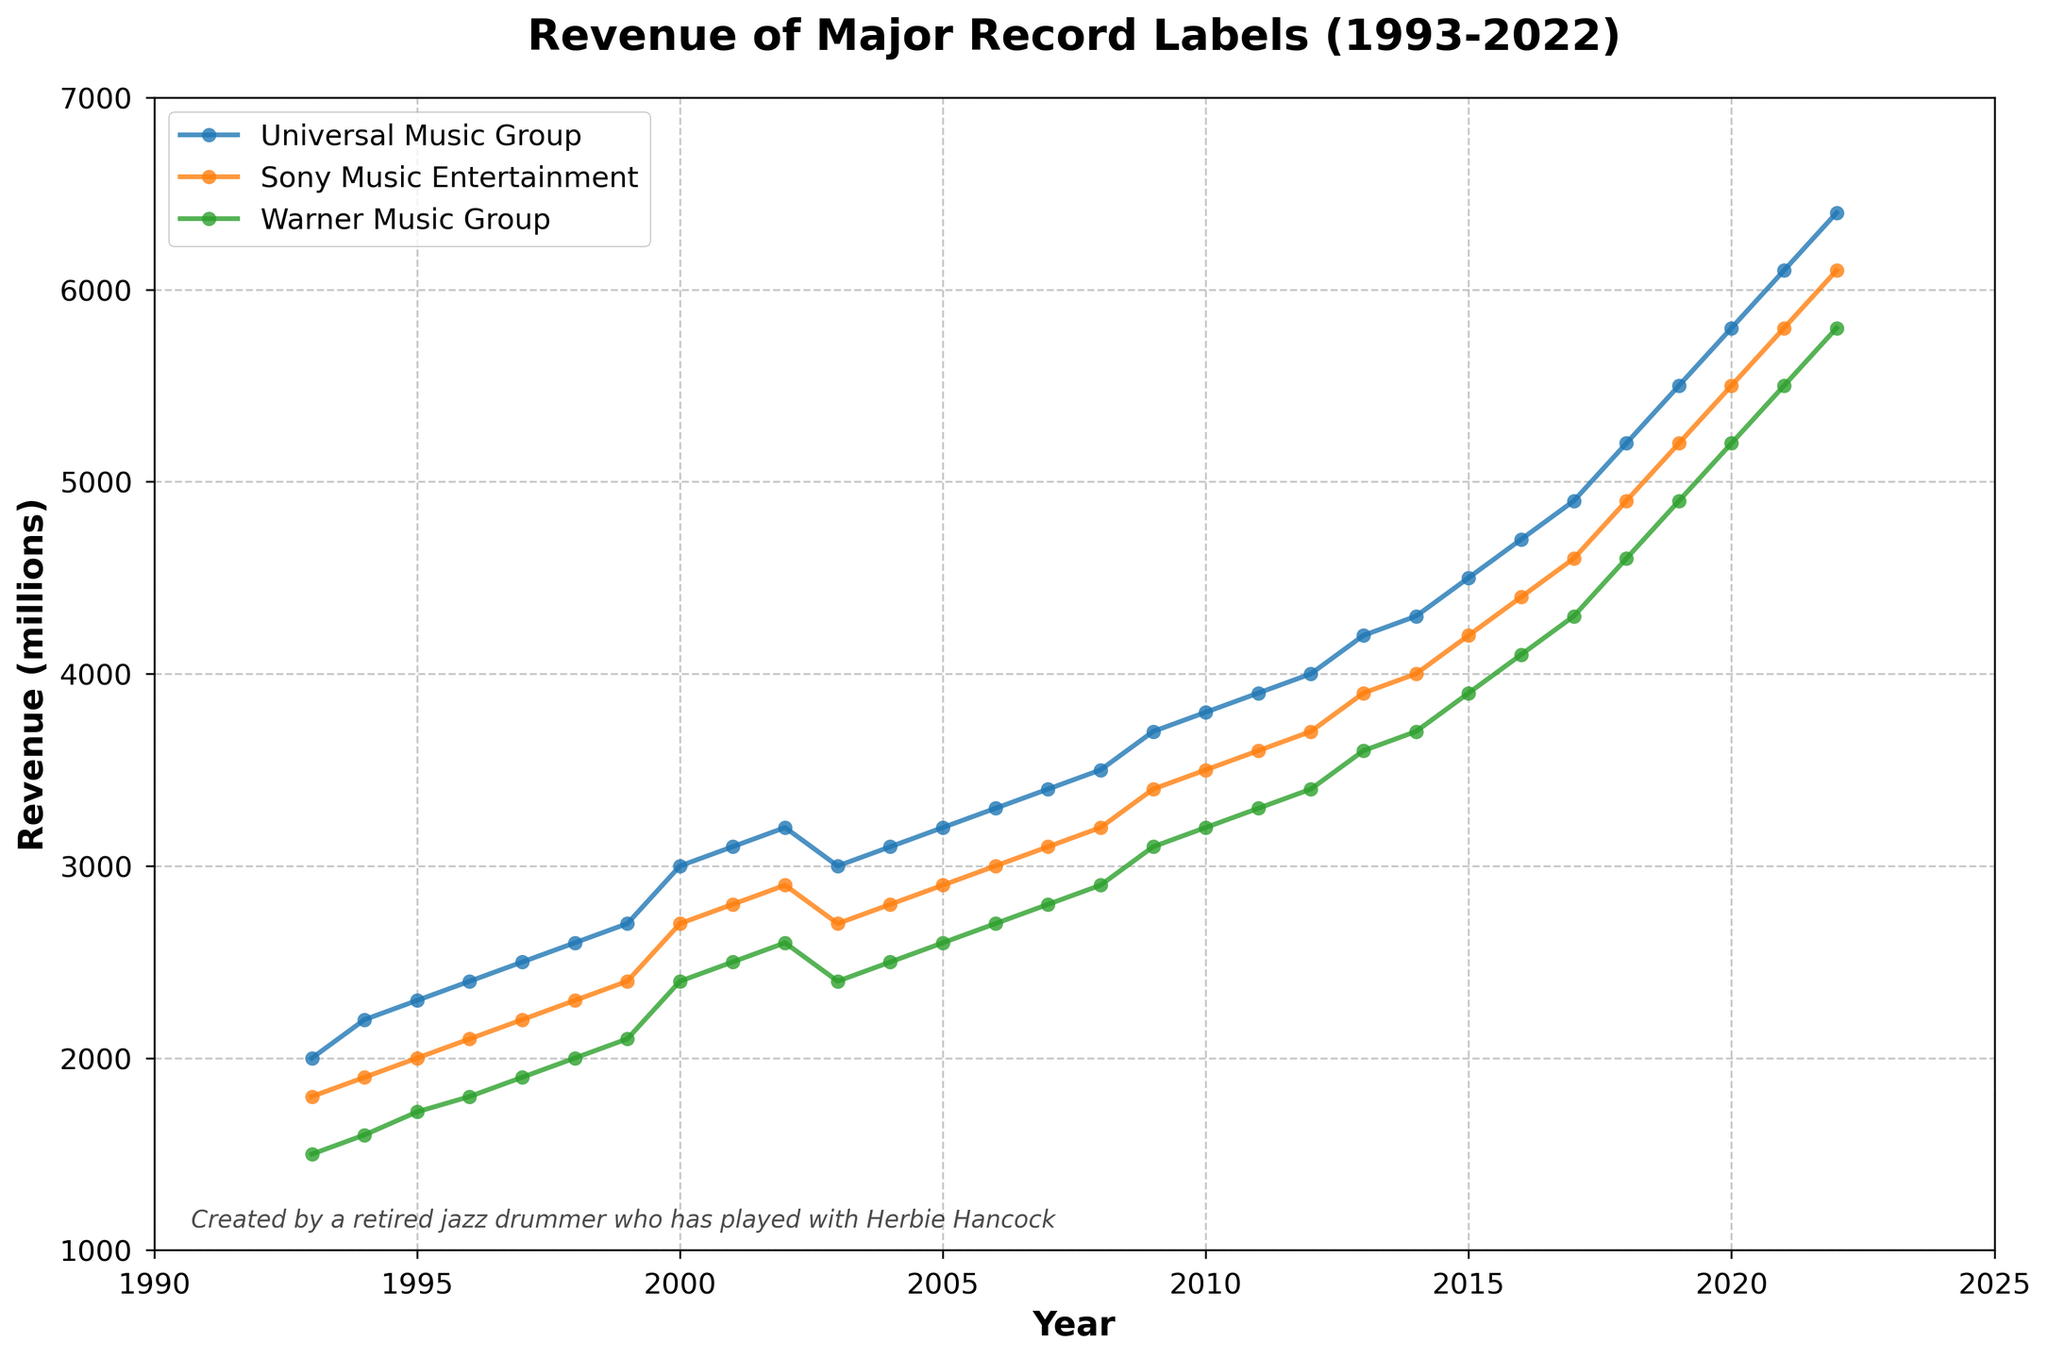what is the title of the figure? The title of the figure is typically placed at the top in a larger, bold font. In this figure, it reads "Revenue of Major Record Labels (1993-2022)".
Answer: Revenue of Major Record Labels (1993-2022) how many record labels' revenues are plotted? By looking carefully at the legend, there are three distinct record labels mentioned: Universal Music Group, Sony Music Entertainment, and Warner Music Group.
Answer: 3 which year shows the highest revenue for Warner Music Group? The plotted line for Warner Music Group peaks in 2022, representing the highest revenue within the given timeframe.
Answer: 2022 between 2010 and 2015, which record label experienced the most significant revenue increase? We calculate the difference between revenues in 2010 and 2015 for each label. Universal Music Group increased from 3800 to 4500 (700 increase), Sony Music from 3500 to 4200 (700 increase), and Warner Music from 3200 to 3900 (700 increase). Since they all have the same increase of 700 millions, none experienced a significantly higher increase.
Answer: None, all increased by 700 millions in which year did Universal Music Group surpass 5000 million in revenue? Observing the plot line for Universal Music Group, its revenue first crosses the 5000 million mark in 2018.
Answer: 2018 did any record label's revenue decrease between 2000 and 2005? The plotted lines all show an upward trend or remain constant; no record label's revenue decreases in this period.
Answer: No what is the average revenue of Sony Music Entertainment from 2000 to 2005? Sum the revenues for Sony Music Entertainment from 2000 to 2005 and divide by the number of years: (2700 + 2800 + 2900 + 2700 + 2800 + 2900) / 6. That's (16800 / 6), yielding an average of 2800 million.
Answer: 2800 million when was the smallest gap between Universal Music Group and Warner Music Group revenues, and what was the amount? Examining the revenue lines, the smallest gap appears in 1999, with Universal having 2700 and Warner having 2100, making the gap (2700 - 2100) 600.
Answer: 1999, 600 million which record label consistently had the lowest revenue from 1993 to 2000? From 1993 to 2000, Warner Music Group's plotted line is always below the others, indicating it consistently had the lowest revenue in that period.
Answer: Warner Music Group how does the revenue trend of Sony Music Entertainment from 2010 to 2020 compare to that of Universal Music Group? Both Sony Music Entertainment and Universal Music Group show consistent upward trends from 2010 to 2020. However, Universal’s trend line is steeper, indicating a faster growth rate.
Answer: Both upward trends, Universal's growth is faster 